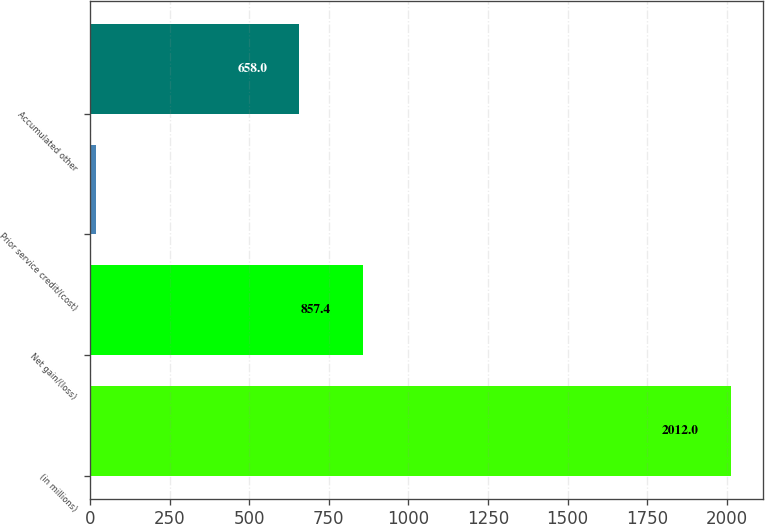Convert chart. <chart><loc_0><loc_0><loc_500><loc_500><bar_chart><fcel>(in millions)<fcel>Net gain/(loss)<fcel>Prior service credit/(cost)<fcel>Accumulated other<nl><fcel>2012<fcel>857.4<fcel>18<fcel>658<nl></chart> 